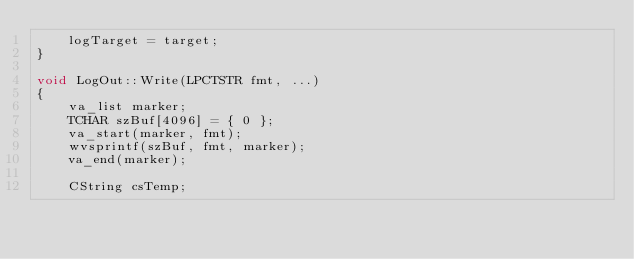Convert code to text. <code><loc_0><loc_0><loc_500><loc_500><_C++_>	logTarget = target;
}

void LogOut::Write(LPCTSTR fmt, ...)
{
	va_list marker;
	TCHAR szBuf[4096] = { 0 };
	va_start(marker, fmt);
	wvsprintf(szBuf, fmt, marker);
	va_end(marker);

	CString csTemp;</code> 